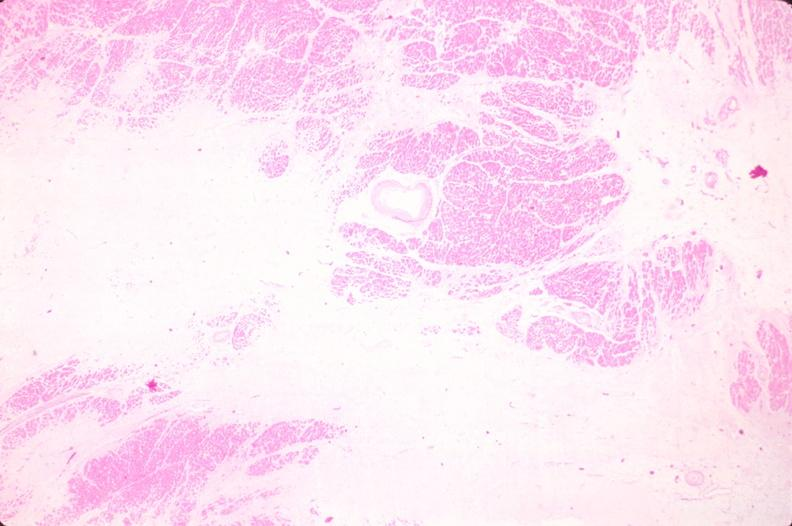what does this image show?
Answer the question using a single word or phrase. Heart 